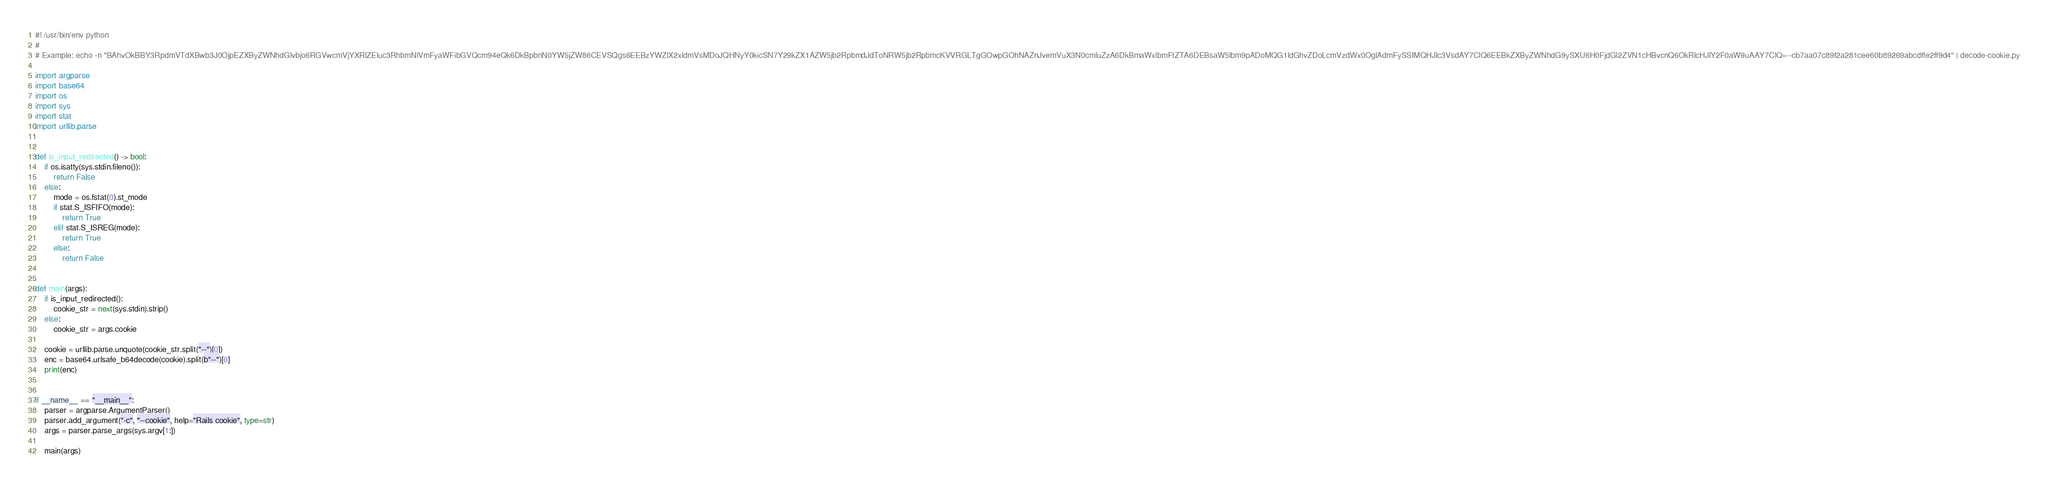<code> <loc_0><loc_0><loc_500><loc_500><_Python_>#! /usr/bin/env python
#
# Example: echo -n "BAhvOkBBY3RpdmVTdXBwb3J0OjpEZXByZWNhdGlvbjo6RGVwcmVjYXRlZEluc3RhbmNlVmFyaWFibGVQcm94eQk6DkBpbnN0YW5jZW86CEVSQgs6EEBzYWZlX2xldmVsMDoJQHNyY0kicSN7Y29kZX1AZW5jb2RpbmdJdToNRW5jb2RpbmcKVVRGLTgGOwpGOhNAZnJvemVuX3N0cmluZzA6DkBmaWxlbmFtZTA6DEBsaW5lbm9pADoMQG1ldGhvZDoLcmVzdWx0OglAdmFySSIMQHJlc3VsdAY7ClQ6EEBkZXByZWNhdG9ySXU6H0FjdGl2ZVN1cHBvcnQ6OkRlcHJlY2F0aW9uAAY7ClQ=--cb7aa07c89f2a281cee60b89269abcdffe2ff9d4" | decode-cookie.py

import argparse
import base64
import os
import sys
import stat
import urllib.parse


def is_input_redirected() -> bool:
    if os.isatty(sys.stdin.fileno()):
        return False
    else:
        mode = os.fstat(0).st_mode
        if stat.S_ISFIFO(mode):
            return True
        elif stat.S_ISREG(mode):
            return True
        else:
            return False


def main(args):
    if is_input_redirected():
        cookie_str = next(sys.stdin).strip()
    else:
        cookie_str = args.cookie

    cookie = urllib.parse.unquote(cookie_str.split("--")[0])
    enc = base64.urlsafe_b64decode(cookie).split(b"--")[0]
    print(enc)


if __name__ == "__main__":
    parser = argparse.ArgumentParser()
    parser.add_argument("-c", "--cookie", help="Rails cookie", type=str)
    args = parser.parse_args(sys.argv[1:])

    main(args)
</code> 